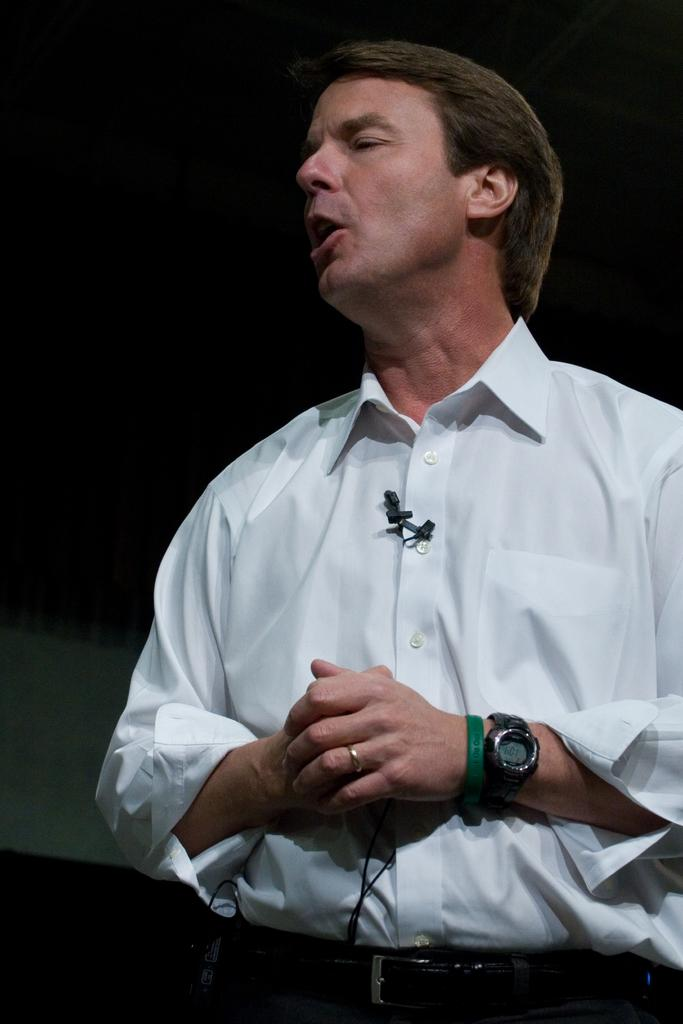Who is the main subject in the image? There is a man in the image. What is the man doing in the image? The man is standing in the image. What object is attached to the man's shirt? There is a microphone attached to the man's shirt. What accessory is the man wearing on his hand? The man is wearing a watch on his hand. What type of art is displayed on the man's sweater in the image? There is no sweater present in the image, and therefore no artwork can be observed on it. 